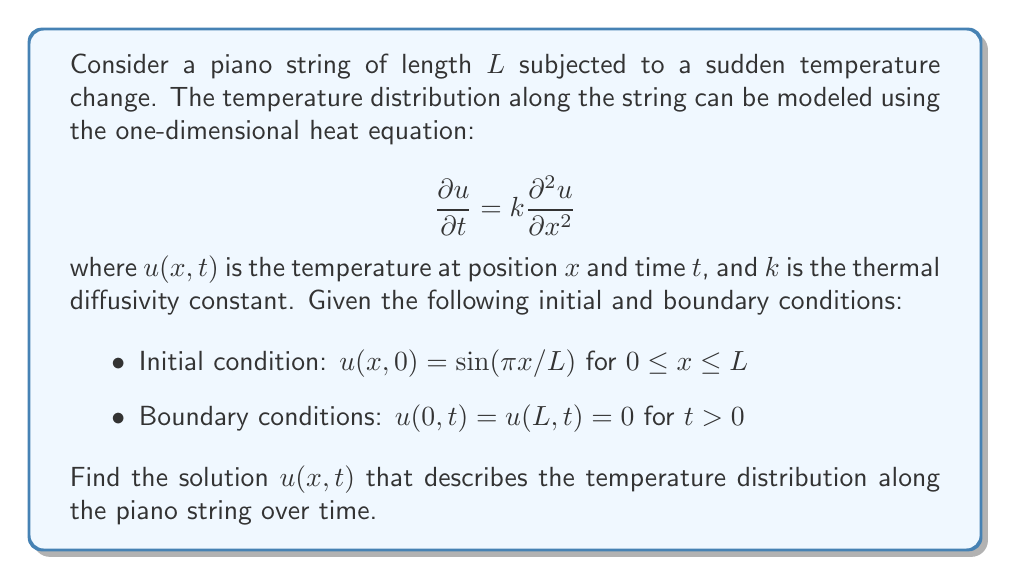Help me with this question. To solve this heat equation problem, we'll use the method of separation of variables:

1) Assume the solution has the form: $u(x,t) = X(x)T(t)$

2) Substituting this into the heat equation:
   $$X(x)T'(t) = kX''(x)T(t)$$
   $$\frac{T'(t)}{kT(t)} = \frac{X''(x)}{X(x)} = -\lambda$$
   where $\lambda$ is a constant.

3) This gives us two ordinary differential equations:
   $$T'(t) + k\lambda T(t) = 0$$
   $$X''(x) + \lambda X(x) = 0$$

4) The boundary conditions imply $X(0) = X(L) = 0$, which leads to the eigenvalue problem:
   $$\lambda_n = \left(\frac{n\pi}{L}\right)^2, \quad X_n(x) = \sin\left(\frac{n\pi x}{L}\right), \quad n = 1,2,3,...$$

5) The general solution for $T(t)$ is:
   $$T_n(t) = e^{-k\lambda_n t} = e^{-k(n\pi/L)^2t}$$

6) The general solution for $u(x,t)$ is:
   $$u(x,t) = \sum_{n=1}^{\infty} A_n \sin\left(\frac{n\pi x}{L}\right)e^{-k(n\pi/L)^2t}$$

7) Using the initial condition to find $A_n$:
   $$\sin\left(\frac{\pi x}{L}\right) = \sum_{n=1}^{\infty} A_n \sin\left(\frac{n\pi x}{L}\right)$$

8) This implies $A_1 = 1$ and $A_n = 0$ for $n > 1$

Therefore, the final solution is:
$$u(x,t) = \sin\left(\frac{\pi x}{L}\right)e^{-k(\pi/L)^2t}$$
Answer: $u(x,t) = \sin\left(\frac{\pi x}{L}\right)e^{-k(\pi/L)^2t}$ 